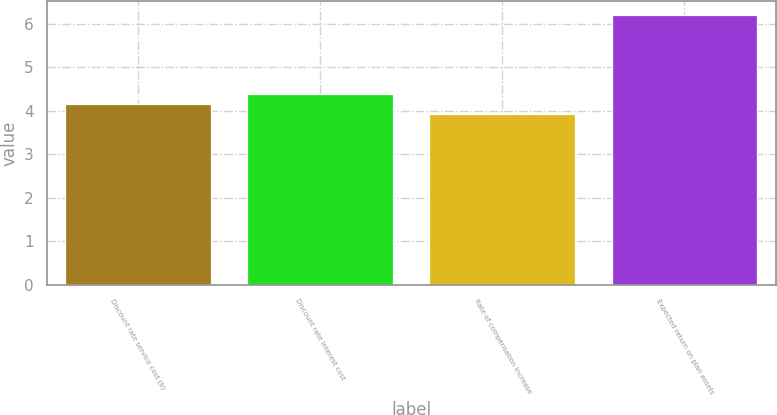Convert chart. <chart><loc_0><loc_0><loc_500><loc_500><bar_chart><fcel>Discount rate service cost (b)<fcel>Discount rate interest cost<fcel>Rate of compensation increase<fcel>Expected return on plan assets<nl><fcel>4.15<fcel>4.38<fcel>3.92<fcel>6.21<nl></chart> 